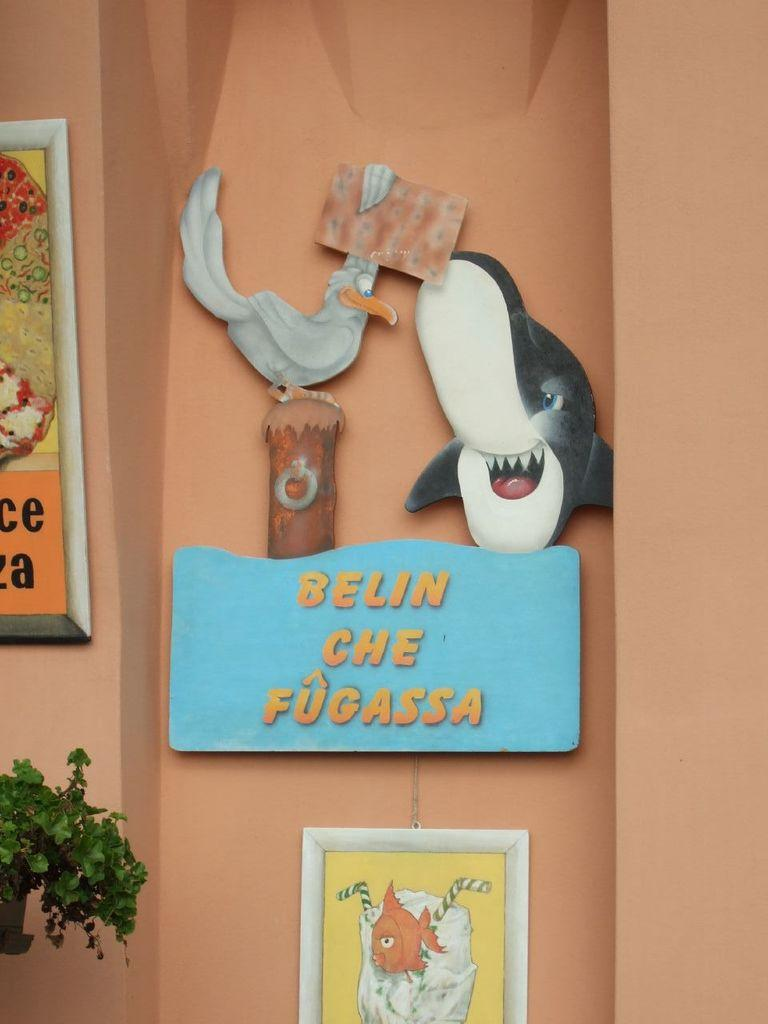What type of structure can be seen in the image? There is a wall in the image. What decorative elements are present in the image? There are banners in the image. What type of statues can be seen in the image? There is a bird statue and an animal statue in the image. What type of vegetation is on the left side of the image? There is a plant on the left side of the image. What type of prose can be seen written on the wall in the image? There is no prose visible on the wall in the image. What type of sticks are used to hold the banners in the image? There are no sticks present in the image; the banners are not held up by any visible supports. 